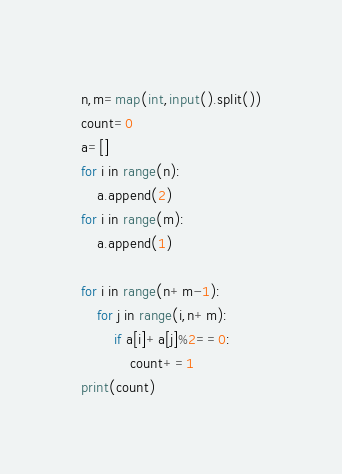Convert code to text. <code><loc_0><loc_0><loc_500><loc_500><_Python_>n,m=map(int,input().split())
count=0
a=[]
for i in range(n):
    a.append(2)
for i in range(m):
    a.append(1)

for i in range(n+m-1):
    for j in range(i,n+m):
        if a[i]+a[j]%2==0:
            count+=1
print(count)</code> 